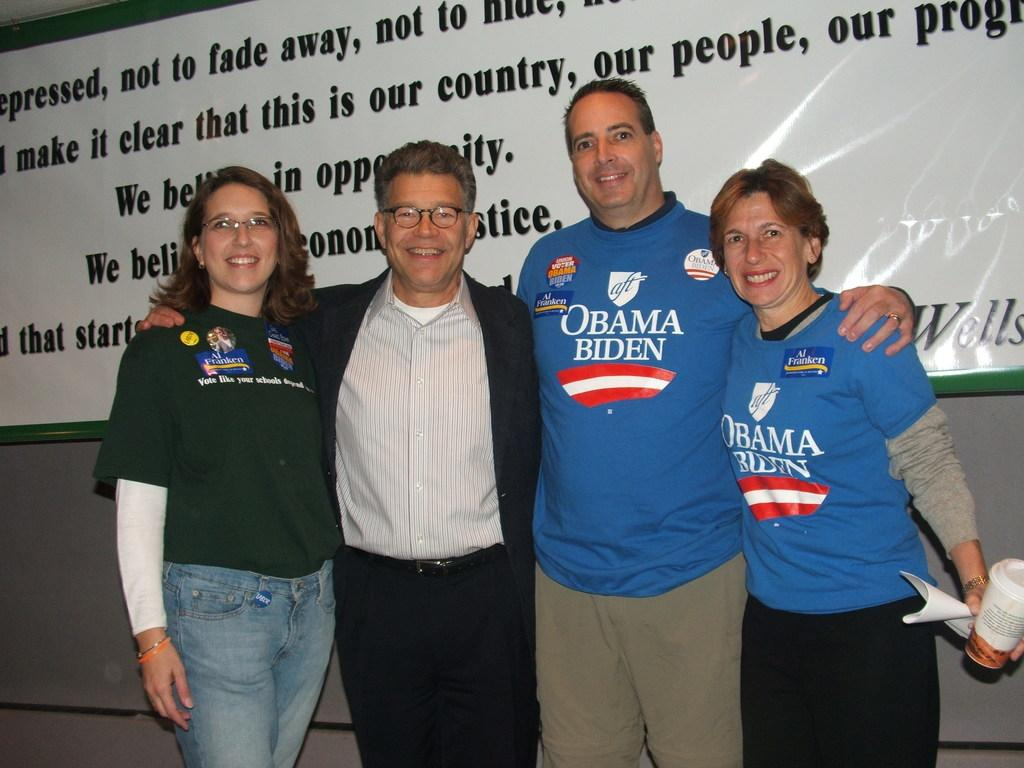<image>
Summarize the visual content of the image. A group of people include two wearing shirts that support the Obama, Biden presidential run. 